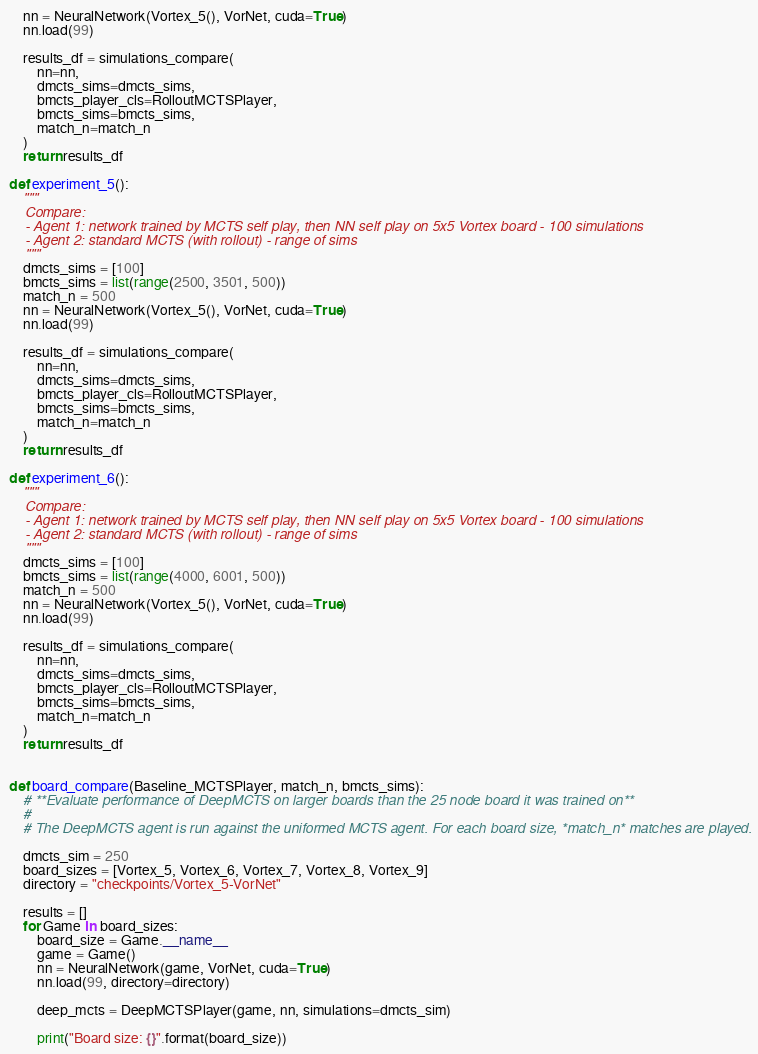<code> <loc_0><loc_0><loc_500><loc_500><_Python_>    nn = NeuralNetwork(Vortex_5(), VorNet, cuda=True)
    nn.load(99)

    results_df = simulations_compare(
        nn=nn,
        dmcts_sims=dmcts_sims, 
        bmcts_player_cls=RolloutMCTSPlayer,
        bmcts_sims=bmcts_sims, 
        match_n=match_n
    )
    return results_df

def experiment_5():
    """
    Compare:
    - Agent 1: network trained by MCTS self play, then NN self play on 5x5 Vortex board - 100 simulations
    - Agent 2: standard MCTS (with rollout) - range of sims
    """
    dmcts_sims = [100]
    bmcts_sims = list(range(2500, 3501, 500))
    match_n = 500
    nn = NeuralNetwork(Vortex_5(), VorNet, cuda=True)
    nn.load(99)

    results_df = simulations_compare(
        nn=nn,
        dmcts_sims=dmcts_sims, 
        bmcts_player_cls=RolloutMCTSPlayer,
        bmcts_sims=bmcts_sims, 
        match_n=match_n
    )
    return results_df

def experiment_6():
    """
    Compare:
    - Agent 1: network trained by MCTS self play, then NN self play on 5x5 Vortex board - 100 simulations
    - Agent 2: standard MCTS (with rollout) - range of sims
    """
    dmcts_sims = [100]
    bmcts_sims = list(range(4000, 6001, 500))
    match_n = 500
    nn = NeuralNetwork(Vortex_5(), VorNet, cuda=True)
    nn.load(99)

    results_df = simulations_compare(
        nn=nn,
        dmcts_sims=dmcts_sims, 
        bmcts_player_cls=RolloutMCTSPlayer,
        bmcts_sims=bmcts_sims, 
        match_n=match_n
    )
    return results_df


def board_compare(Baseline_MCTSPlayer, match_n, bmcts_sims):
    # **Evaluate performance of DeepMCTS on larger boards than the 25 node board it was trained on**
    # 
    # The DeepMCTS agent is run against the uniformed MCTS agent. For each board size, *match_n* matches are played.

    dmcts_sim = 250
    board_sizes = [Vortex_5, Vortex_6, Vortex_7, Vortex_8, Vortex_9]
    directory = "checkpoints/Vortex_5-VorNet"

    results = []
    for Game in board_sizes:
        board_size = Game.__name__
        game = Game()
        nn = NeuralNetwork(game, VorNet, cuda=True)
        nn.load(99, directory=directory)

        deep_mcts = DeepMCTSPlayer(game, nn, simulations=dmcts_sim)

        print("Board size: {}".format(board_size))
</code> 